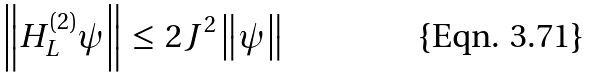Convert formula to latex. <formula><loc_0><loc_0><loc_500><loc_500>\left \| H _ { L } ^ { ( 2 ) } \psi \right \| \, \leq \, 2 J ^ { 2 } \left \| \psi \right \|</formula> 